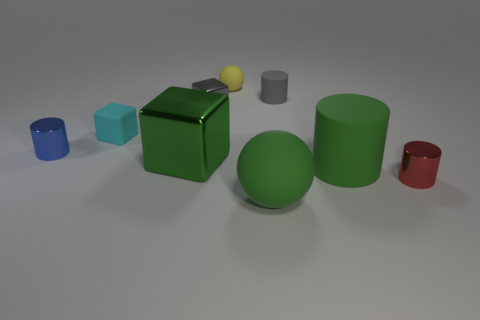Do the gray cylinder and the blue object have the same size?
Give a very brief answer. Yes. Are there more blocks than large cyan cubes?
Give a very brief answer. Yes. What number of shiny objects are big green cylinders or small blue cylinders?
Offer a terse response. 1. What number of big rubber spheres are the same color as the small ball?
Offer a terse response. 0. What material is the sphere in front of the tiny cylinder behind the matte object to the left of the green shiny thing made of?
Offer a very short reply. Rubber. There is a small shiny object in front of the large metallic thing that is in front of the blue metal object; what color is it?
Provide a succinct answer. Red. What number of big things are blue objects or gray cylinders?
Provide a short and direct response. 0. What number of green cylinders are the same material as the small gray block?
Give a very brief answer. 0. What is the size of the shiny thing that is in front of the large green cylinder?
Your response must be concise. Small. There is a green object that is left of the ball that is behind the small red metallic cylinder; what is its shape?
Ensure brevity in your answer.  Cube. 